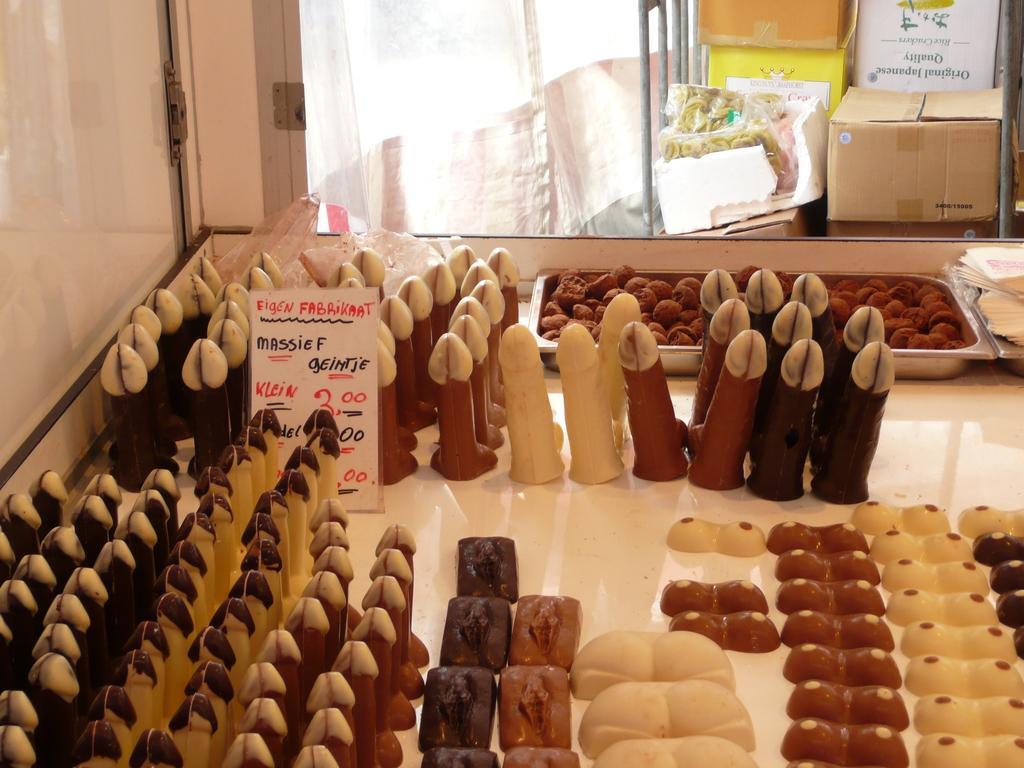In one or two sentences, can you explain what this image depicts? In this image, we can see some food items on the white colored surface. Among them, we can see some food items in a container. We can also see a board with some text. We can see the wall. We can also see a stand with some objects like a few cardboard boxes and also some objects packed with covers. We can also see the white colored object. 